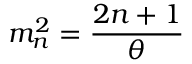<formula> <loc_0><loc_0><loc_500><loc_500>m _ { n } ^ { 2 } = { \frac { 2 n + 1 } { \theta } }</formula> 